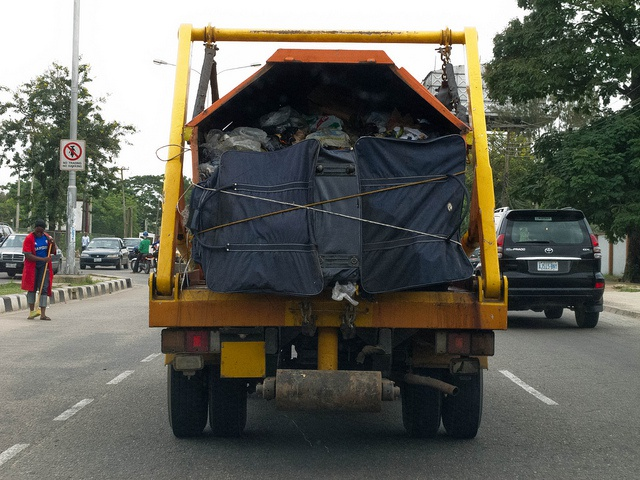Describe the objects in this image and their specific colors. I can see truck in white, black, and maroon tones, suitcase in white, black, gray, and darkblue tones, car in white, black, gray, purple, and darkblue tones, suitcase in white, black, and gray tones, and people in white, black, brown, gray, and maroon tones in this image. 